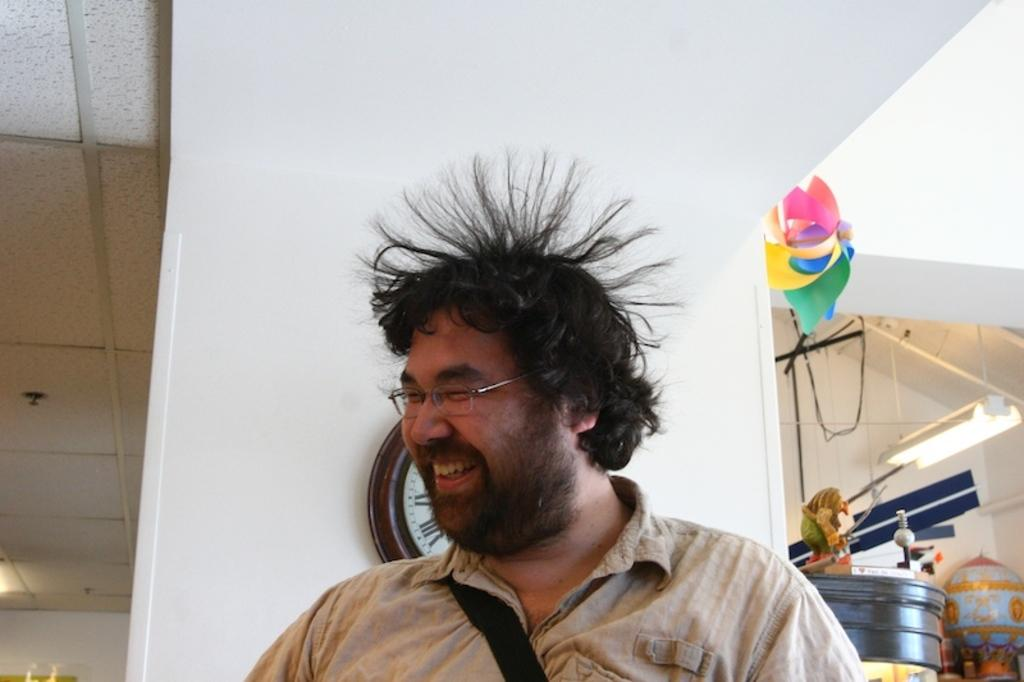What is the color of the wall in the image? The wall in the image is white. What object can be used to tell time in the image? There is a clock in the image. What musical instrument is present in the image? There is a drum in the image. Who is the person standing in the image? There is a man standing in the front of the image. What type of cap is the man wearing in the image? There is no cap visible in the image; the man is not wearing one. How does the man's memory affect the objects in the image? The man's memory is not mentioned in the image, so it cannot affect the objects. 